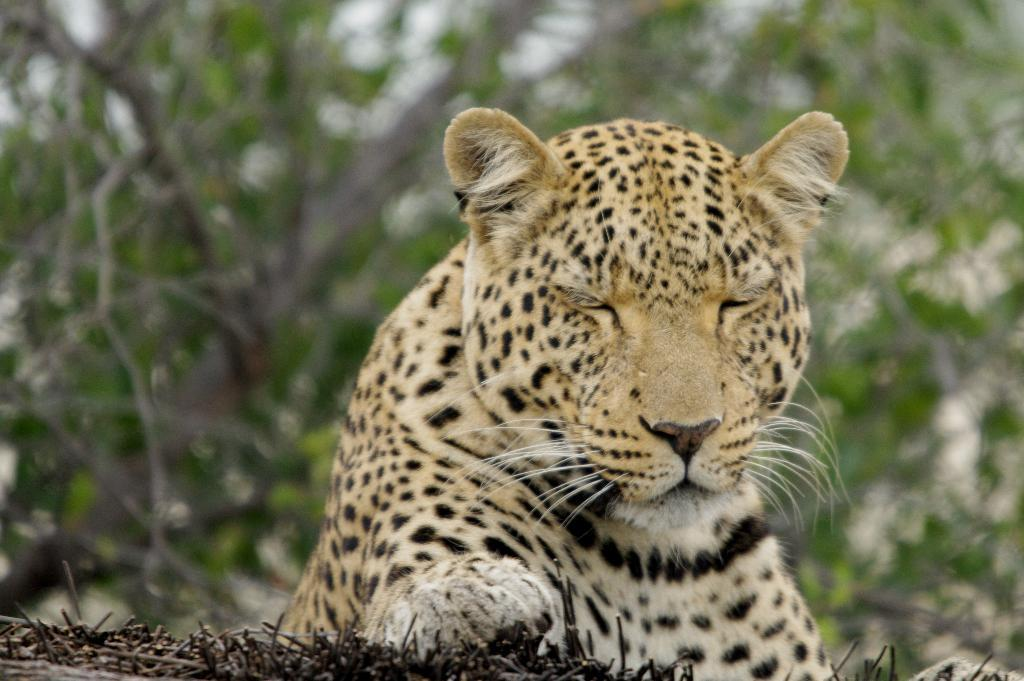What type of animal is in the image? There is a tiger in the image. What colors can be seen on the tiger? The tiger has a yellow and black color combination. Where is the tiger located in the image? The tiger is on the ground. What can be seen in the background of the image? There are trees in the background of the image. How is the background of the image depicted? The background is blurred. How does the tiger help the mother manage her wealth in the image? There is no mention of a mother or wealth in the image; it simply features a tiger on the ground with trees in the background. 